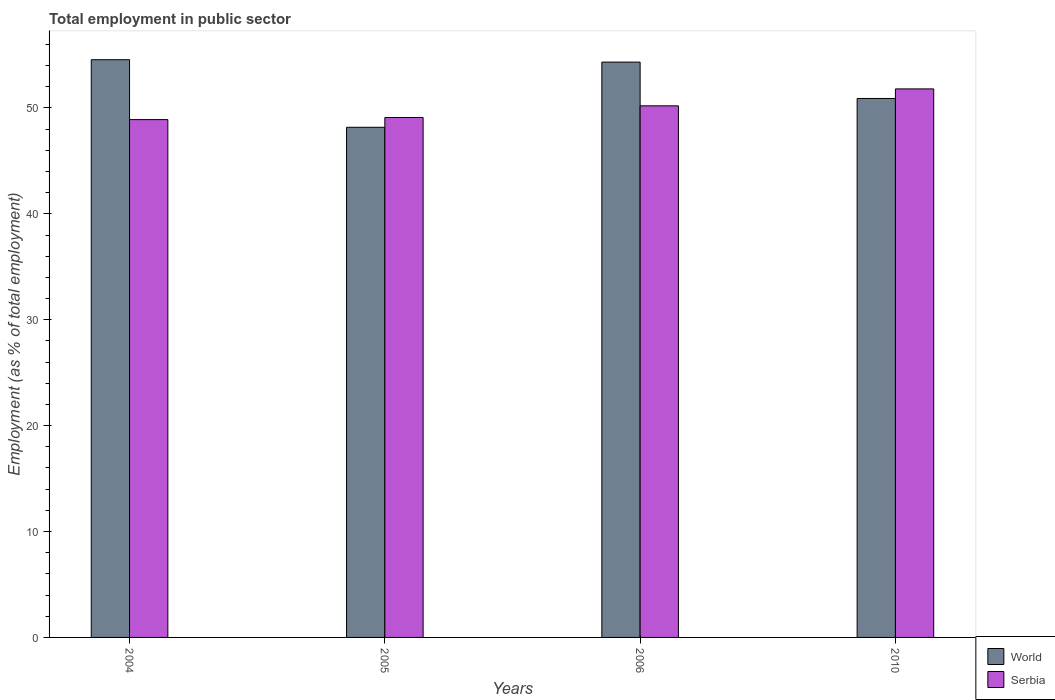How many different coloured bars are there?
Keep it short and to the point. 2. Are the number of bars per tick equal to the number of legend labels?
Offer a terse response. Yes. Are the number of bars on each tick of the X-axis equal?
Offer a terse response. Yes. How many bars are there on the 4th tick from the left?
Offer a terse response. 2. What is the employment in public sector in Serbia in 2006?
Ensure brevity in your answer.  50.2. Across all years, what is the maximum employment in public sector in Serbia?
Offer a terse response. 51.8. Across all years, what is the minimum employment in public sector in Serbia?
Make the answer very short. 48.9. In which year was the employment in public sector in Serbia maximum?
Your answer should be very brief. 2010. What is the total employment in public sector in World in the graph?
Provide a short and direct response. 207.96. What is the difference between the employment in public sector in World in 2005 and that in 2006?
Your response must be concise. -6.16. What is the difference between the employment in public sector in World in 2005 and the employment in public sector in Serbia in 2006?
Your answer should be compact. -2.03. What is the average employment in public sector in World per year?
Offer a terse response. 51.99. In the year 2006, what is the difference between the employment in public sector in Serbia and employment in public sector in World?
Offer a terse response. -4.13. In how many years, is the employment in public sector in Serbia greater than 20 %?
Your answer should be very brief. 4. What is the ratio of the employment in public sector in Serbia in 2004 to that in 2005?
Provide a succinct answer. 1. Is the employment in public sector in Serbia in 2004 less than that in 2010?
Offer a very short reply. Yes. What is the difference between the highest and the second highest employment in public sector in World?
Keep it short and to the point. 0.23. What is the difference between the highest and the lowest employment in public sector in World?
Provide a short and direct response. 6.38. What does the 2nd bar from the left in 2004 represents?
Provide a succinct answer. Serbia. What does the 1st bar from the right in 2005 represents?
Offer a very short reply. Serbia. Are all the bars in the graph horizontal?
Your answer should be very brief. No. How many years are there in the graph?
Provide a short and direct response. 4. What is the difference between two consecutive major ticks on the Y-axis?
Ensure brevity in your answer.  10. Are the values on the major ticks of Y-axis written in scientific E-notation?
Ensure brevity in your answer.  No. Does the graph contain any zero values?
Ensure brevity in your answer.  No. Where does the legend appear in the graph?
Make the answer very short. Bottom right. How are the legend labels stacked?
Offer a terse response. Vertical. What is the title of the graph?
Your answer should be compact. Total employment in public sector. What is the label or title of the Y-axis?
Ensure brevity in your answer.  Employment (as % of total employment). What is the Employment (as % of total employment) in World in 2004?
Ensure brevity in your answer.  54.56. What is the Employment (as % of total employment) of Serbia in 2004?
Offer a terse response. 48.9. What is the Employment (as % of total employment) in World in 2005?
Offer a terse response. 48.17. What is the Employment (as % of total employment) of Serbia in 2005?
Provide a short and direct response. 49.1. What is the Employment (as % of total employment) in World in 2006?
Your answer should be compact. 54.33. What is the Employment (as % of total employment) of Serbia in 2006?
Your answer should be very brief. 50.2. What is the Employment (as % of total employment) of World in 2010?
Your response must be concise. 50.9. What is the Employment (as % of total employment) of Serbia in 2010?
Keep it short and to the point. 51.8. Across all years, what is the maximum Employment (as % of total employment) in World?
Your answer should be compact. 54.56. Across all years, what is the maximum Employment (as % of total employment) of Serbia?
Make the answer very short. 51.8. Across all years, what is the minimum Employment (as % of total employment) in World?
Keep it short and to the point. 48.17. Across all years, what is the minimum Employment (as % of total employment) of Serbia?
Give a very brief answer. 48.9. What is the total Employment (as % of total employment) of World in the graph?
Your response must be concise. 207.96. What is the difference between the Employment (as % of total employment) in World in 2004 and that in 2005?
Give a very brief answer. 6.38. What is the difference between the Employment (as % of total employment) of Serbia in 2004 and that in 2005?
Your response must be concise. -0.2. What is the difference between the Employment (as % of total employment) of World in 2004 and that in 2006?
Make the answer very short. 0.23. What is the difference between the Employment (as % of total employment) in Serbia in 2004 and that in 2006?
Make the answer very short. -1.3. What is the difference between the Employment (as % of total employment) in World in 2004 and that in 2010?
Ensure brevity in your answer.  3.66. What is the difference between the Employment (as % of total employment) in World in 2005 and that in 2006?
Ensure brevity in your answer.  -6.16. What is the difference between the Employment (as % of total employment) of Serbia in 2005 and that in 2006?
Your answer should be very brief. -1.1. What is the difference between the Employment (as % of total employment) in World in 2005 and that in 2010?
Keep it short and to the point. -2.72. What is the difference between the Employment (as % of total employment) in Serbia in 2005 and that in 2010?
Keep it short and to the point. -2.7. What is the difference between the Employment (as % of total employment) in World in 2006 and that in 2010?
Make the answer very short. 3.44. What is the difference between the Employment (as % of total employment) of Serbia in 2006 and that in 2010?
Make the answer very short. -1.6. What is the difference between the Employment (as % of total employment) of World in 2004 and the Employment (as % of total employment) of Serbia in 2005?
Provide a short and direct response. 5.46. What is the difference between the Employment (as % of total employment) in World in 2004 and the Employment (as % of total employment) in Serbia in 2006?
Keep it short and to the point. 4.36. What is the difference between the Employment (as % of total employment) in World in 2004 and the Employment (as % of total employment) in Serbia in 2010?
Provide a short and direct response. 2.76. What is the difference between the Employment (as % of total employment) in World in 2005 and the Employment (as % of total employment) in Serbia in 2006?
Make the answer very short. -2.03. What is the difference between the Employment (as % of total employment) in World in 2005 and the Employment (as % of total employment) in Serbia in 2010?
Give a very brief answer. -3.63. What is the difference between the Employment (as % of total employment) in World in 2006 and the Employment (as % of total employment) in Serbia in 2010?
Offer a very short reply. 2.53. What is the average Employment (as % of total employment) of World per year?
Provide a succinct answer. 51.99. In the year 2004, what is the difference between the Employment (as % of total employment) in World and Employment (as % of total employment) in Serbia?
Keep it short and to the point. 5.66. In the year 2005, what is the difference between the Employment (as % of total employment) in World and Employment (as % of total employment) in Serbia?
Give a very brief answer. -0.93. In the year 2006, what is the difference between the Employment (as % of total employment) in World and Employment (as % of total employment) in Serbia?
Make the answer very short. 4.13. In the year 2010, what is the difference between the Employment (as % of total employment) in World and Employment (as % of total employment) in Serbia?
Make the answer very short. -0.9. What is the ratio of the Employment (as % of total employment) in World in 2004 to that in 2005?
Keep it short and to the point. 1.13. What is the ratio of the Employment (as % of total employment) in Serbia in 2004 to that in 2006?
Your answer should be very brief. 0.97. What is the ratio of the Employment (as % of total employment) of World in 2004 to that in 2010?
Offer a very short reply. 1.07. What is the ratio of the Employment (as % of total employment) of Serbia in 2004 to that in 2010?
Keep it short and to the point. 0.94. What is the ratio of the Employment (as % of total employment) in World in 2005 to that in 2006?
Your response must be concise. 0.89. What is the ratio of the Employment (as % of total employment) in Serbia in 2005 to that in 2006?
Your answer should be very brief. 0.98. What is the ratio of the Employment (as % of total employment) in World in 2005 to that in 2010?
Offer a very short reply. 0.95. What is the ratio of the Employment (as % of total employment) in Serbia in 2005 to that in 2010?
Your answer should be compact. 0.95. What is the ratio of the Employment (as % of total employment) in World in 2006 to that in 2010?
Your answer should be very brief. 1.07. What is the ratio of the Employment (as % of total employment) of Serbia in 2006 to that in 2010?
Offer a terse response. 0.97. What is the difference between the highest and the second highest Employment (as % of total employment) in World?
Ensure brevity in your answer.  0.23. What is the difference between the highest and the lowest Employment (as % of total employment) in World?
Your answer should be very brief. 6.38. 